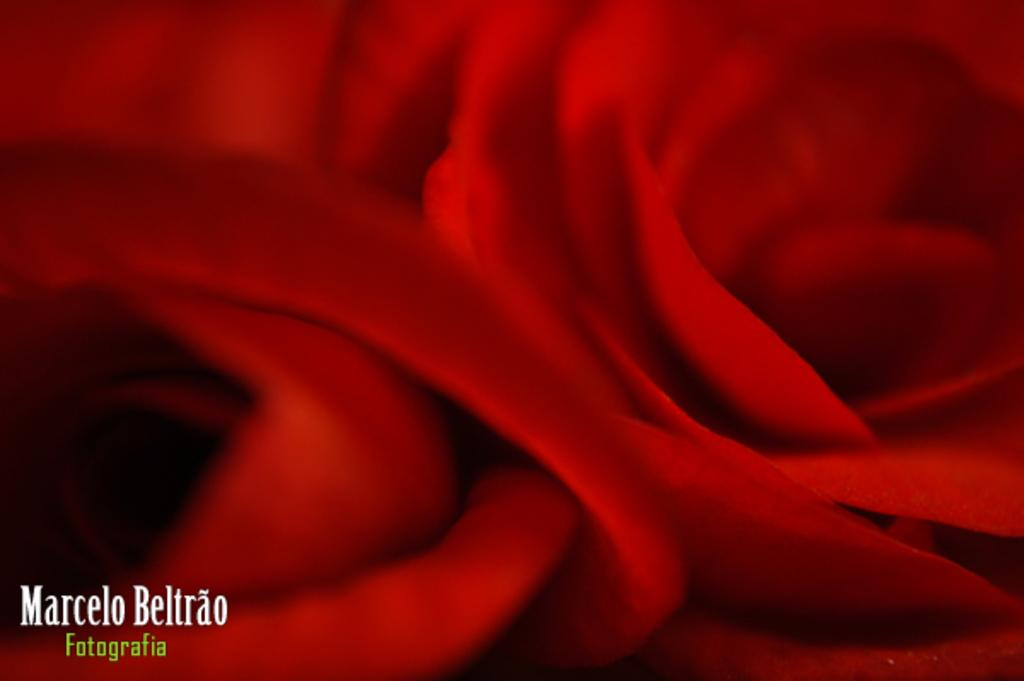What type of flower is in the image? There is a red color flower in the image. Where is the flower located in the image? The flower is in the middle of the image. What else can be seen in the image besides the flower? There is text in the bottom left corner of the image. Can you hear the song being sung by the flower in the image? There is no song being sung by the flower in the image, as flowers do not have the ability to sing. 